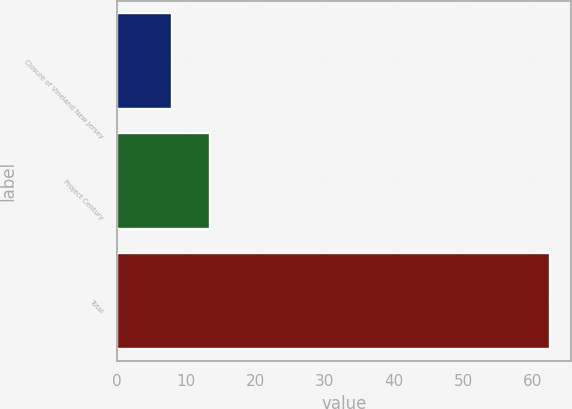Convert chart to OTSL. <chart><loc_0><loc_0><loc_500><loc_500><bar_chart><fcel>Closure of Vineland New Jersey<fcel>Project Century<fcel>Total<nl><fcel>7.9<fcel>13.36<fcel>62.5<nl></chart> 